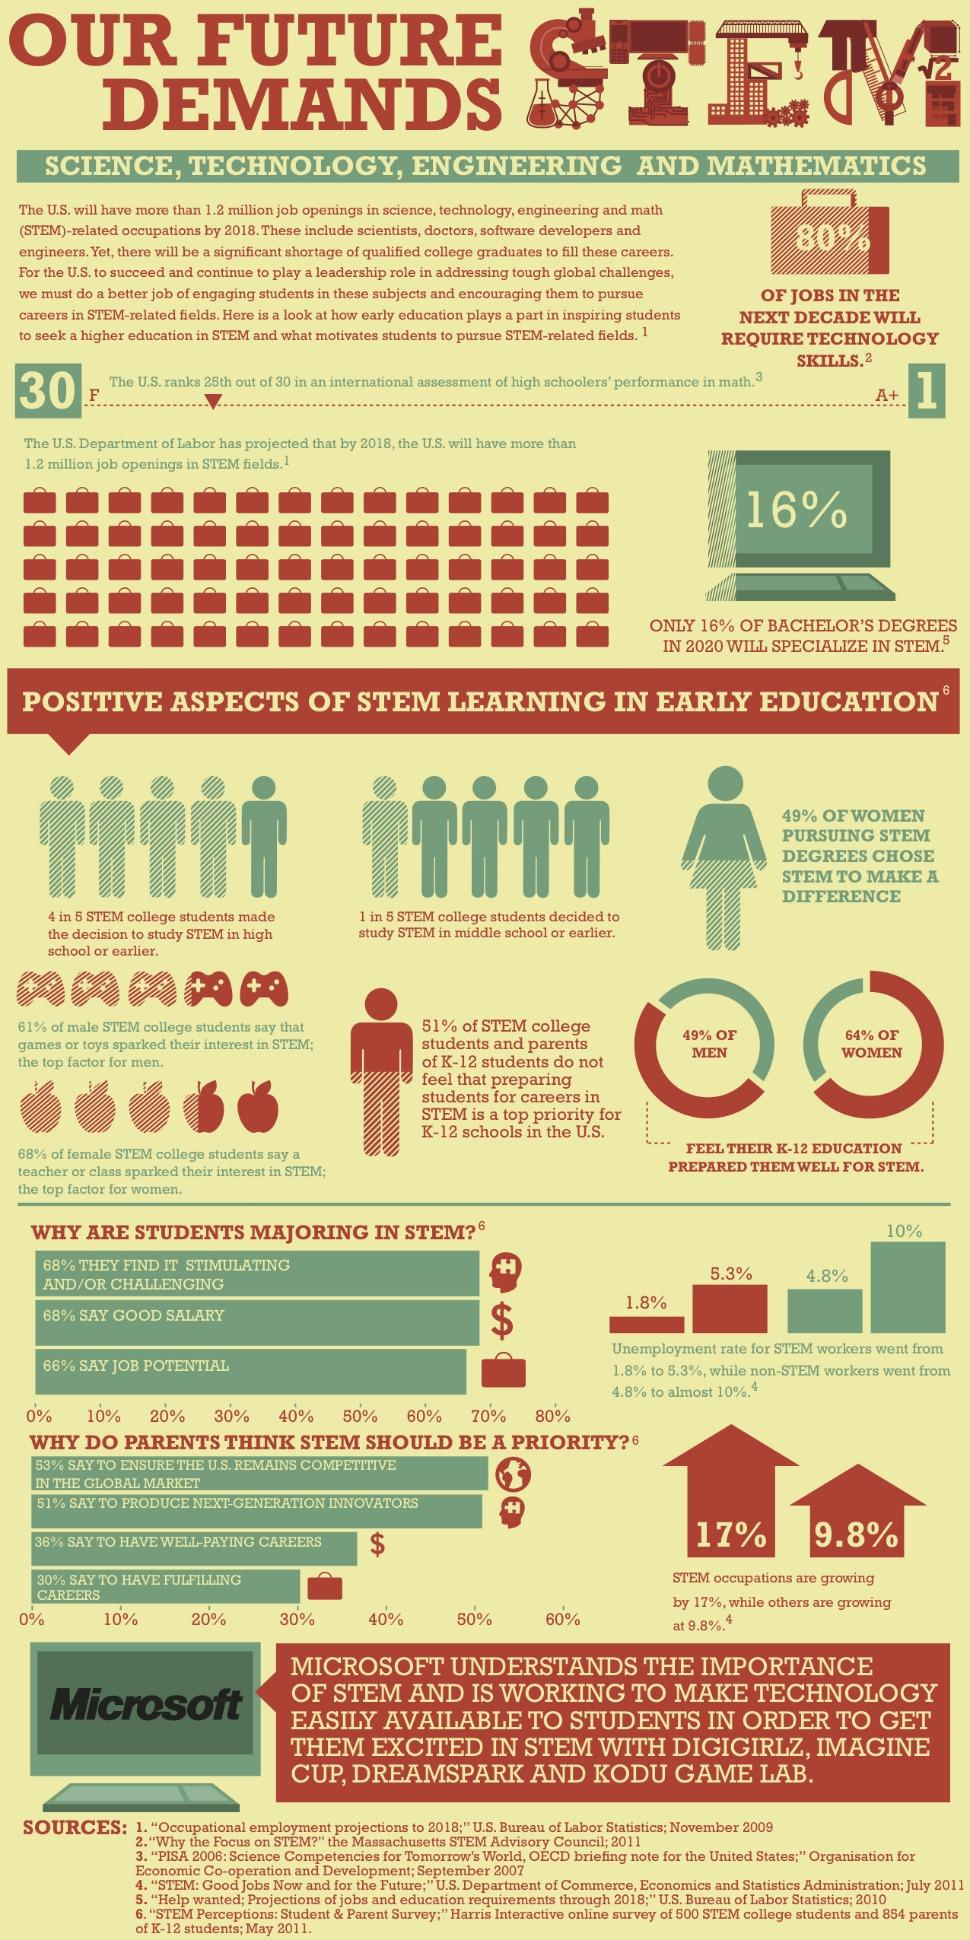Point out several critical features in this image. The growth rate of STEM jobs is significantly higher compared to other jobs, at 7.2%. A recent survey found that 51% of men believe that K-12 education does not adequately prepare them for a career in STEM (science, technology, engineering, and math). According to a recent survey, 36% of women believe that their K-12 exam will not adequately prepare them for a career in STEM fields. 